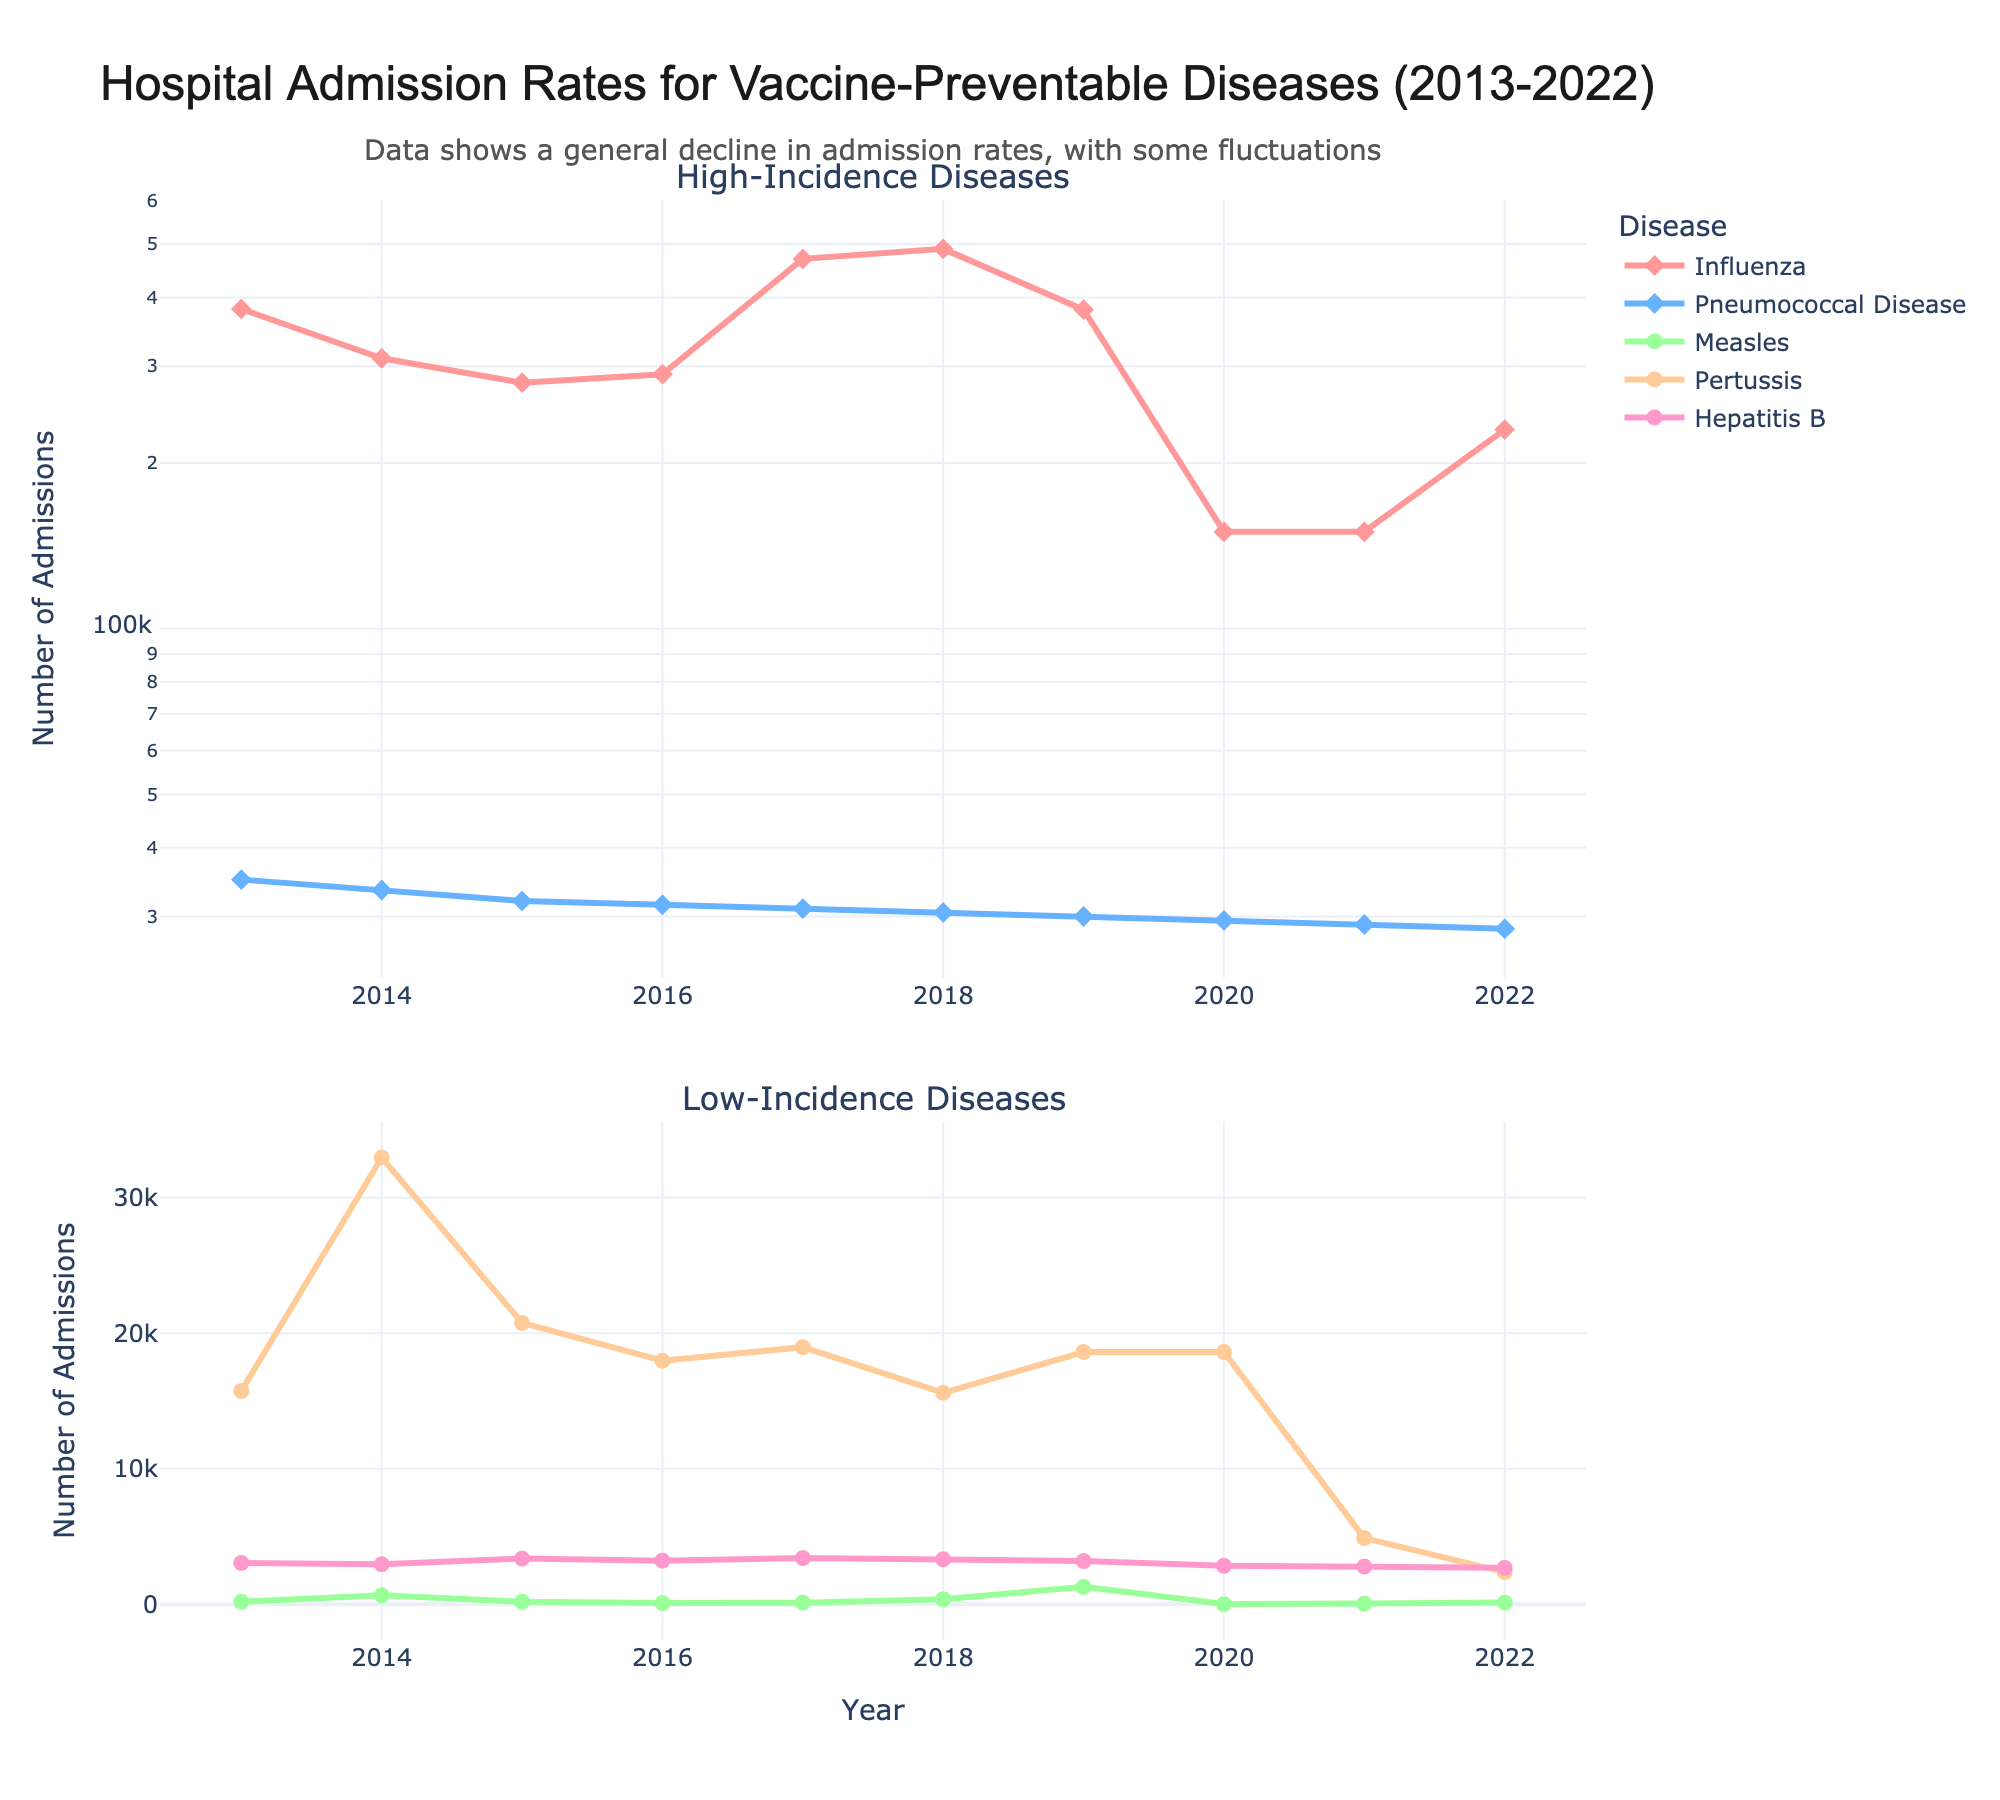What's the general trend of hospital admissions for Influenza and Pneumococcal Disease over the decade? From the figure, we can see that the number of hospital admissions for Influenza has generally fluctuated but shows a significant decline in 2020. For Pneumococcal Disease, the number of admissions has a slight decreasing trend over the years, with some fluctuations.
Answer: Both diseases show a general decline with fluctuations How do hospital admissions for Measles compare between 2013 and 2019? By comparing the points on the plot, we can see that admissions for Measles in 2019 (1282) are significantly higher than in 2013 (187).
Answer: Higher in 2019 What is the average hospital admission rate for Pertussis over the last decade? To find the average, add up the Pertussis admissions for each year and divide by the number of years. (15737 + 32971 + 20762 + 17972 + 18975 + 15609 + 18617 + 18617 + 4885 + 2368) / 10 = 16651.3
Answer: 16651.3 Which disease had the greatest drop in admissions from 2019 to 2020? From the figure, check the downfall from 2019 to 2020 for all diseases. Influenza shows the biggest drop from 380000 to 150000, which is a significant reduction.
Answer: Influenza For the years 2021 and 2022, how much did the hospital admissions for Hepatitis B decrease? Subtract the Hepatitis B admissions in 2022 (2688) from 2021 (2780). 2780 - 2688 = 92
Answer: 92 Which year had the lowest hospital admissions for Measles? By examining the Measles trend in the figure, we can identify that the year with the lowest admissions is 2020 (13).
Answer: 2020 How many times higher were the hospital admissions for Pertussis in 2014 compared to 2021? Divide Pertussis admissions in 2014 (32971) by those in 2021 (4885). 32971 / 4885 ≈ 6.75
Answer: 6.75 What distinct pattern can be observed in hospital admissions due to Influenza in 2020 and 2021? By referring to the figure, it is clear that Influenza admissions dropped drastically in 2020 and remained very low in 2021, which might be influenced by the COVID-19 pandemic.
Answer: Significant drop and continued low levels Which disease shows the most consistent trend over the years? From the figure, Hepatitis B shows a relatively consistent trend with slight fluctuations compared to other diseases.
Answer: Hepatitis B 